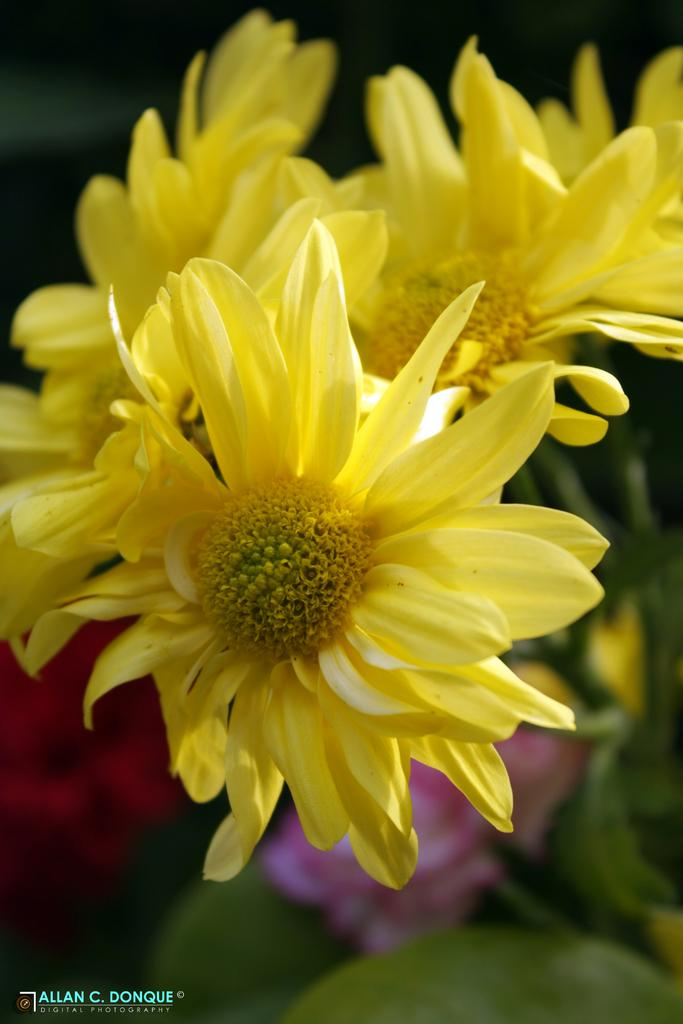What type of flowers can be seen in the image? There are yellow color flowers in the image. Can you describe the background of the image? The background of the image is blurred. Is there any additional information or marking on the image? Yes, there is a watermark on the image. What type of advice does the doctor give in the image? There is no doctor present in the image, so it is not possible to answer that question. 